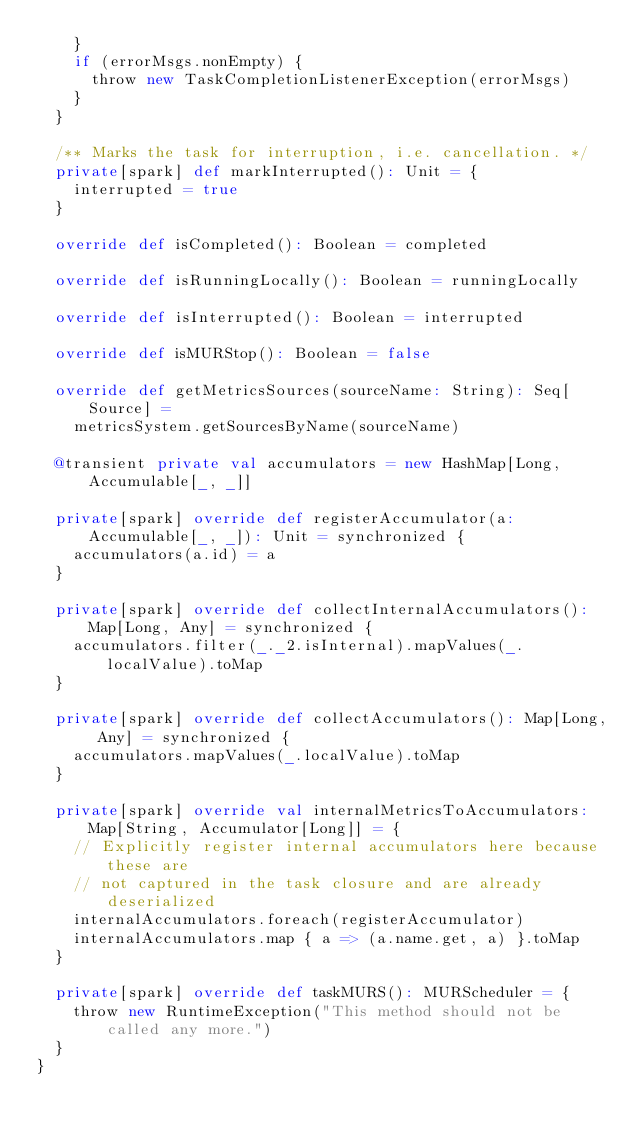Convert code to text. <code><loc_0><loc_0><loc_500><loc_500><_Scala_>    }
    if (errorMsgs.nonEmpty) {
      throw new TaskCompletionListenerException(errorMsgs)
    }
  }

  /** Marks the task for interruption, i.e. cancellation. */
  private[spark] def markInterrupted(): Unit = {
    interrupted = true
  }

  override def isCompleted(): Boolean = completed

  override def isRunningLocally(): Boolean = runningLocally

  override def isInterrupted(): Boolean = interrupted

  override def isMURStop(): Boolean = false

  override def getMetricsSources(sourceName: String): Seq[Source] =
    metricsSystem.getSourcesByName(sourceName)

  @transient private val accumulators = new HashMap[Long, Accumulable[_, _]]

  private[spark] override def registerAccumulator(a: Accumulable[_, _]): Unit = synchronized {
    accumulators(a.id) = a
  }

  private[spark] override def collectInternalAccumulators(): Map[Long, Any] = synchronized {
    accumulators.filter(_._2.isInternal).mapValues(_.localValue).toMap
  }

  private[spark] override def collectAccumulators(): Map[Long, Any] = synchronized {
    accumulators.mapValues(_.localValue).toMap
  }

  private[spark] override val internalMetricsToAccumulators: Map[String, Accumulator[Long]] = {
    // Explicitly register internal accumulators here because these are
    // not captured in the task closure and are already deserialized
    internalAccumulators.foreach(registerAccumulator)
    internalAccumulators.map { a => (a.name.get, a) }.toMap
  }

  private[spark] override def taskMURS(): MURScheduler = {
    throw new RuntimeException("This method should not be called any more.")
  }
}
</code> 